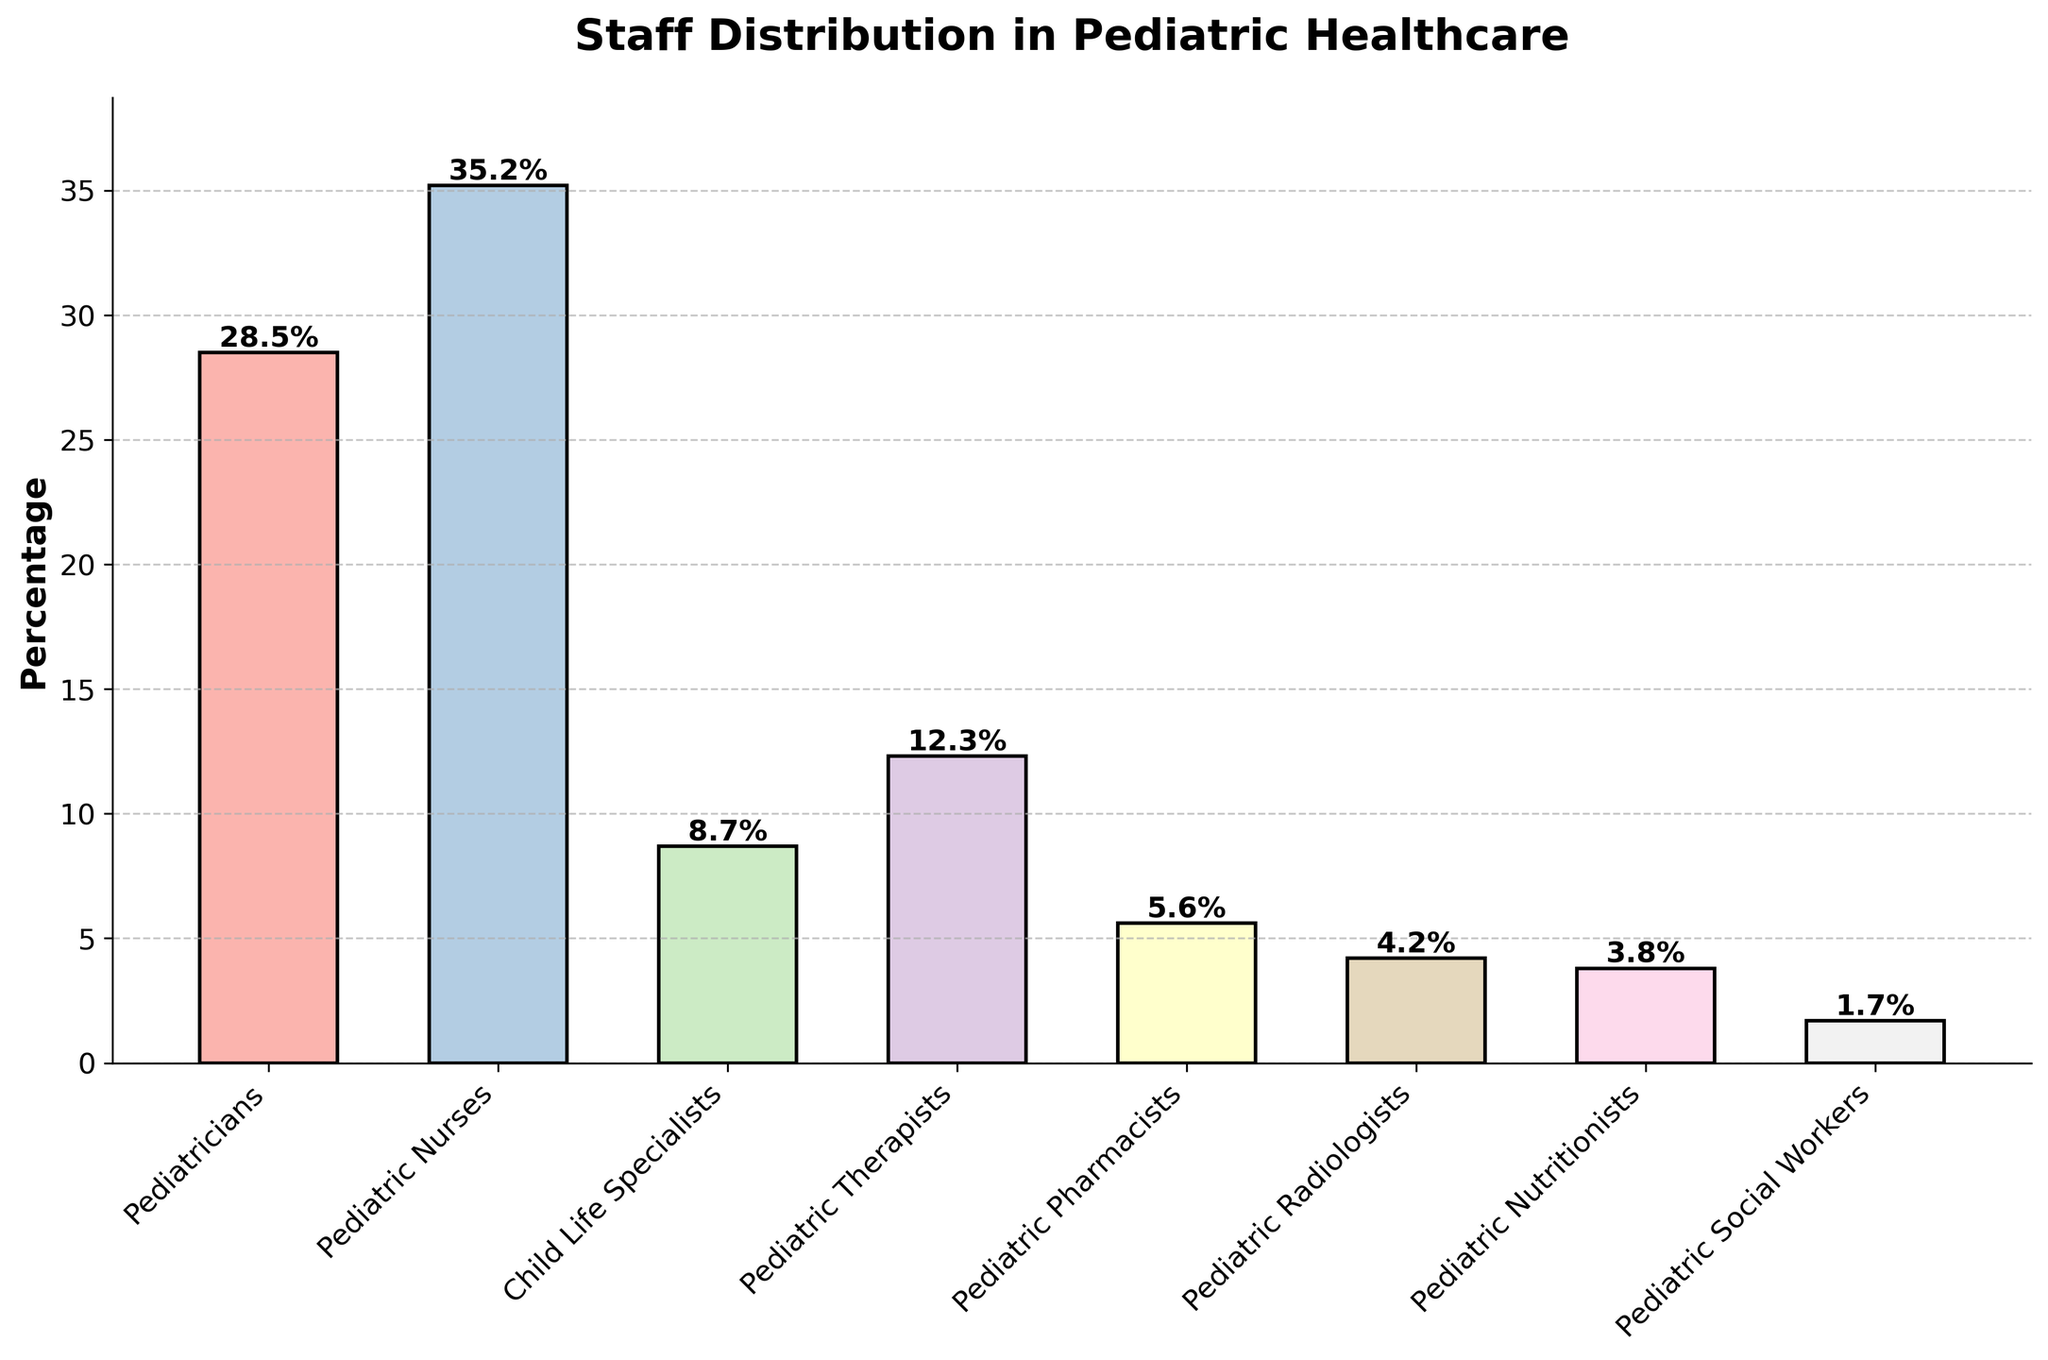What's the role with the highest staff percentage? By visual inspection of the bar chart, the tallest bar corresponds to Pediatric Nurses.
Answer: Pediatric Nurses What's the total percentage of Pediatric Therapists, Pediatric Pharmacists, and Pediatric Radiologists combined? Look for the percentages of Pediatric Therapists (12.3%), Pediatric Pharmacists (5.6%), and Pediatric Radiologists (4.2%). Adding them gives 12.3 + 5.6 + 4.2 = 22.1%.
Answer: 22.1% What's the percentage difference between Pediatricians and Child Life Specialists? Find the percentages for Pediatricians (28.5%) and Child Life Specialists (8.7%). Subtract the lower percentage from the higher one: 28.5 - 8.7 = 19.8%.
Answer: 19.8% Which role has a lower percentage, Pediatric Nutritionists or Pediatric Social Workers? Compare the heights of the bars for Pediatric Nutritionists (3.8%) and Pediatric Social Workers (1.7%).
Answer: Pediatric Social Workers Which roles have percentages below 5%? Identify the bars with heights below the 5% mark. These roles are Pediatric Pharmacists (5.6%), Pediatric Radiologists (4.2%), Pediatric Nutritionists (3.8%), and Pediatric Social Workers (1.7%).
Answer: Pediatric Radiologists, Pediatric Nutritionists, Pediatric Social Workers What's the combined percentage of roles involved in direct patient support (Child Life Specialists and Pediatric Social Workers)? Add the percentages for Child Life Specialists (8.7%) and Pediatric Social Workers (1.7%) together: 8.7 + 1.7 = 10.4%.
Answer: 10.4% Which role has a taller bar, Pediatric Pharmacists or Pediatric Nutritionists? Comparing the heights, Pediatric Pharmacists (5.6%) have a taller bar than Pediatric Nutritionists (3.8%).
Answer: Pediatric Pharmacists What's the percentage of the staff that are neither Pediatricians nor Pediatric Nurses? Add the percentages of all roles except Pediatricians (28.5%) and Pediatric Nurses (35.2%): 8.7 + 12.3 + 5.6 + 4.2 + 3.8 + 1.7 = 36.3%.
Answer: 36.3% Among Pediatric Therapists, Pediatric Pharmacists, and Pediatric Radiologists, which role has the smallest staff percentage? Compare the percentages: Pediatric Therapists (12.3%), Pediatric Pharmacists (5.6%), and Pediatric Radiologists (4.2%).
Answer: Pediatric Radiologists 